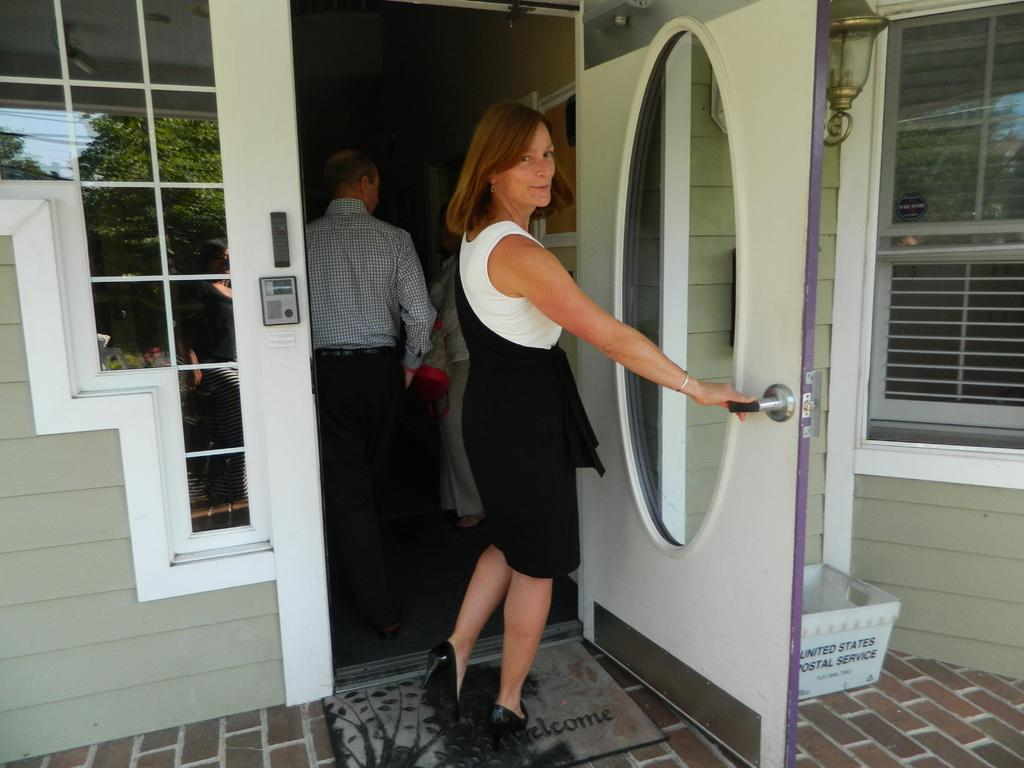How many persons are in the image? There are persons standing in the image. Where are the persons standing? The persons are standing on the floor. What objects can be seen in the image besides the persons? There is a door, a bin, and an electric light in the image. What is visible in the mirror in the image? The reflection of trees, the sky, and cables is visible in the mirror. What type of quince can be seen in the image? There is no quince present in the image. Is the image taken in a library? The provided facts do not mention a library, so it cannot be determined from the image. 